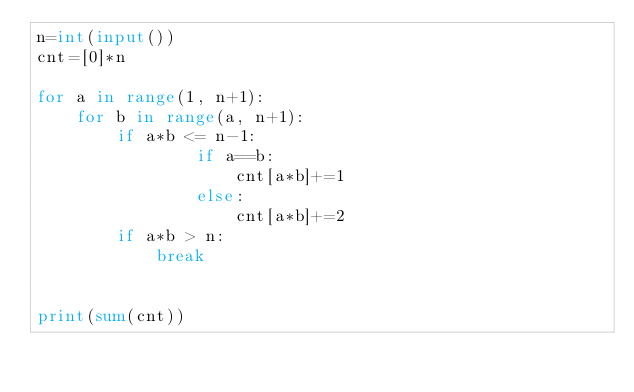Convert code to text. <code><loc_0><loc_0><loc_500><loc_500><_Python_>n=int(input())
cnt=[0]*n

for a in range(1, n+1):
    for b in range(a, n+1):
        if a*b <= n-1:
                if a==b:
                    cnt[a*b]+=1
                else:
                    cnt[a*b]+=2
        if a*b > n:
            break


print(sum(cnt))
</code> 